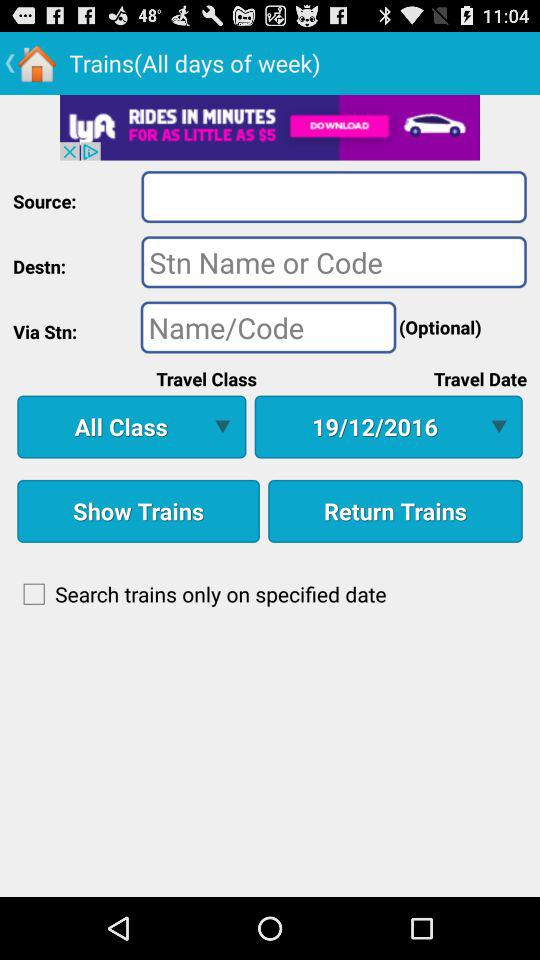What's the selected travel class? The selected travel class is "All Class". 